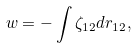Convert formula to latex. <formula><loc_0><loc_0><loc_500><loc_500>w = - \int \zeta _ { 1 2 } d r _ { 1 2 } ,</formula> 